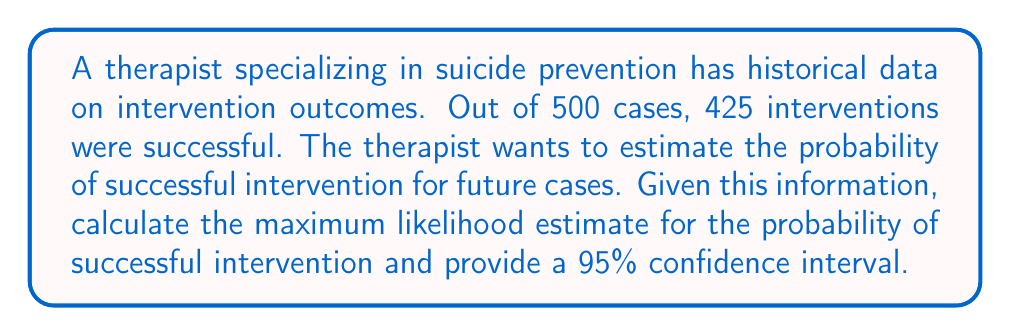Solve this math problem. To solve this inverse problem, we'll use the maximum likelihood estimation (MLE) method and construct a confidence interval.

Step 1: Calculate the maximum likelihood estimate (MLE)
The MLE for the probability of success (p) is simply the proportion of successful interventions:

$$ \hat{p} = \frac{\text{Number of successful interventions}}{\text{Total number of cases}} = \frac{425}{500} = 0.85 $$

Step 2: Calculate the standard error (SE) of the estimate
The standard error for a proportion is given by:

$$ SE = \sqrt{\frac{\hat{p}(1-\hat{p})}{n}} $$

Where $n$ is the total number of cases. Substituting our values:

$$ SE = \sqrt{\frac{0.85(1-0.85)}{500}} = \sqrt{\frac{0.1275}{500}} \approx 0.0159 $$

Step 3: Construct the 95% confidence interval
For a 95% confidence interval, we use the z-score of 1.96. The formula is:

$$ CI = \hat{p} \pm 1.96 \times SE $$

Lower bound: $0.85 - 1.96 \times 0.0159 \approx 0.8188$
Upper bound: $0.85 + 1.96 \times 0.0159 \approx 0.8812$

Therefore, the 95% confidence interval is approximately (0.8188, 0.8812).
Answer: MLE: 0.85; 95% CI: (0.8188, 0.8812) 